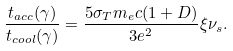Convert formula to latex. <formula><loc_0><loc_0><loc_500><loc_500>\frac { t _ { a c c } ( \gamma ) } { t _ { c o o l } ( \gamma ) } = \frac { 5 \sigma _ { T } m _ { e } c ( 1 + D ) } { 3 e ^ { 2 } } \xi \nu _ { s } .</formula> 